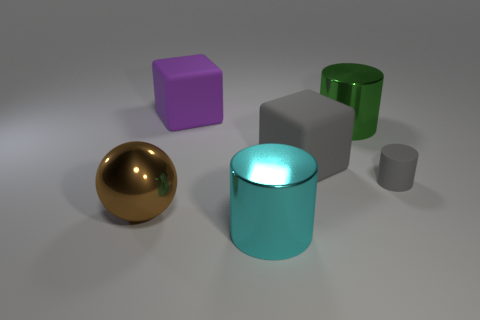There is a thing that is in front of the metallic sphere; does it have the same color as the tiny cylinder?
Offer a very short reply. No. Is the number of tiny gray cylinders to the right of the large green metallic cylinder the same as the number of tiny gray cylinders behind the small matte thing?
Offer a terse response. No. Is there anything else that has the same material as the cyan object?
Keep it short and to the point. Yes. There is a cylinder in front of the gray cylinder; what color is it?
Provide a succinct answer. Cyan. Is the number of brown balls that are to the left of the brown sphere the same as the number of big gray objects?
Keep it short and to the point. No. What number of other things are there of the same shape as the tiny gray rubber thing?
Offer a terse response. 2. There is a big green shiny thing; how many large purple things are left of it?
Make the answer very short. 1. There is a thing that is on the left side of the large gray rubber object and behind the large sphere; how big is it?
Give a very brief answer. Large. Are any gray blocks visible?
Keep it short and to the point. Yes. How many other things are there of the same size as the ball?
Keep it short and to the point. 4. 